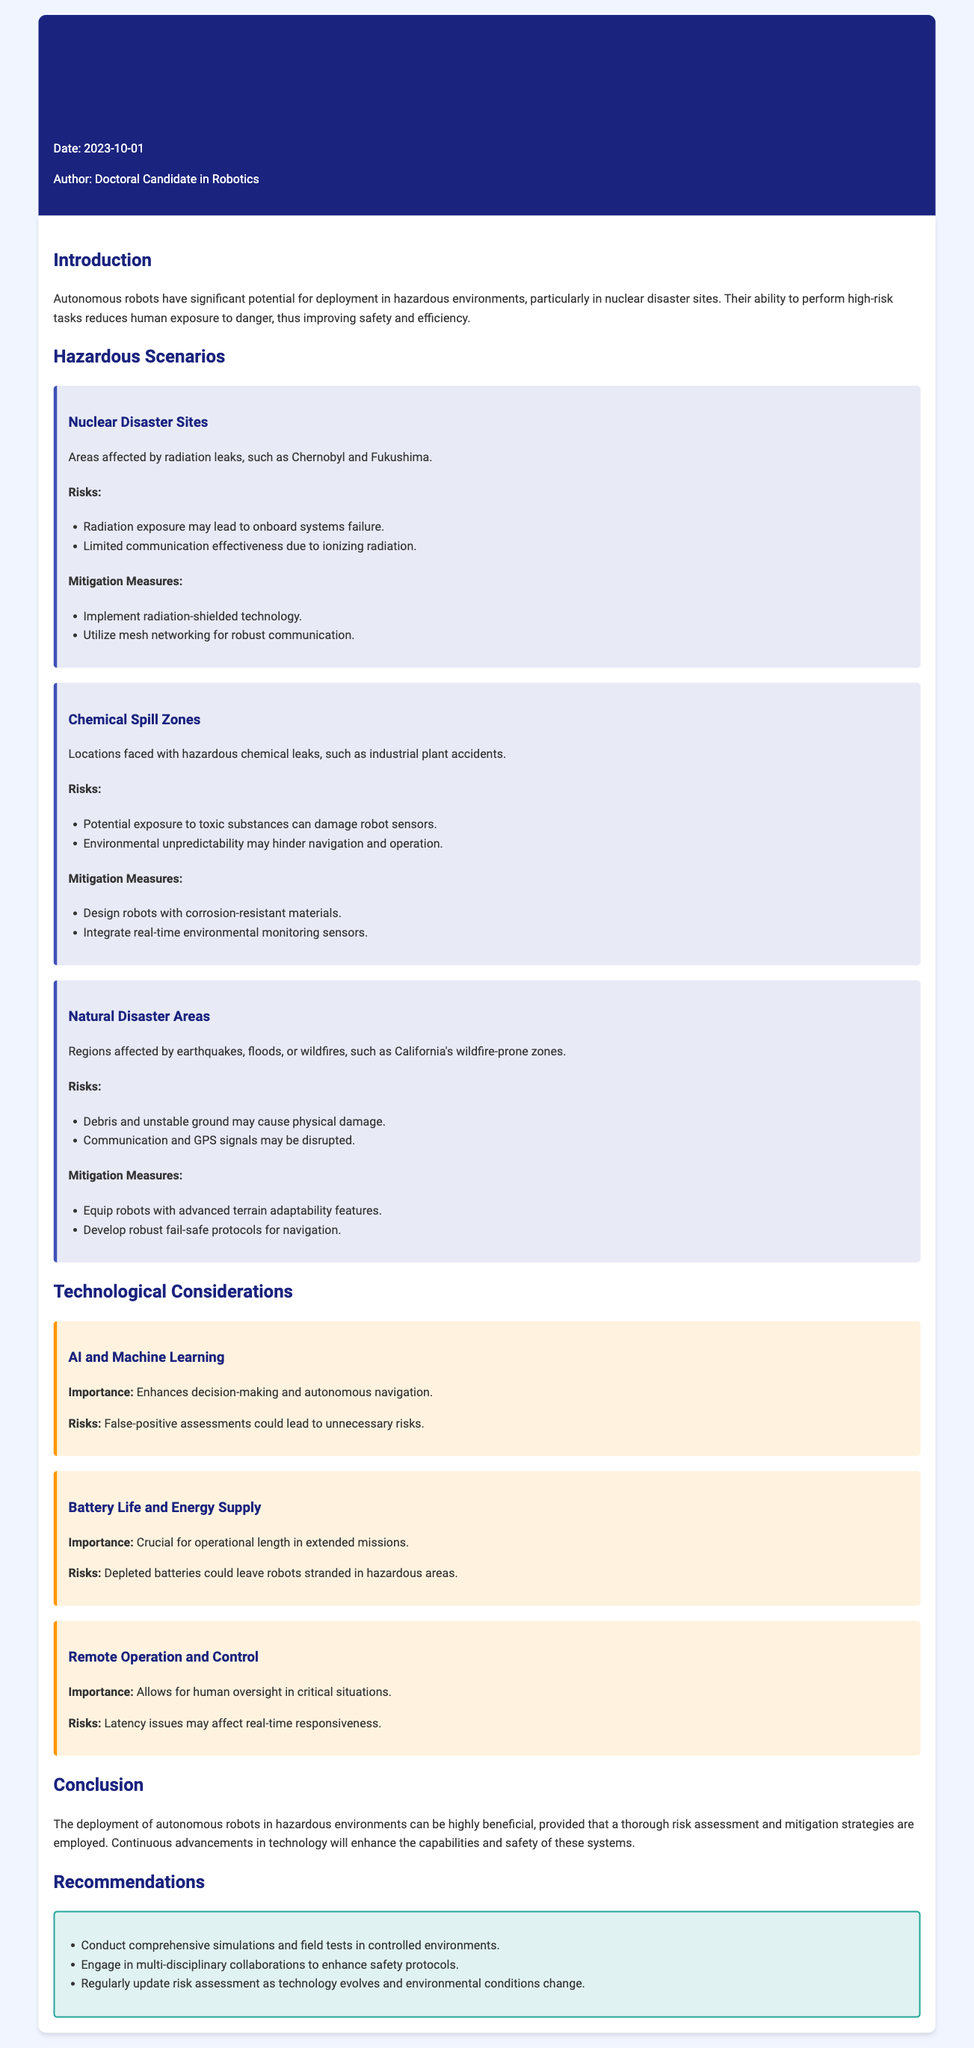What is the date of the report? The date of the report is stated in the memo header of the document.
Answer: 2023-10-01 Who is the author of the report? The author is identified in the memo header, which specifies the author's role.
Answer: Doctoral Candidate in Robotics What are the two main hazards in nuclear disaster sites? The risks associated with nuclear disaster sites are listed under the relevant scenario section.
Answer: Radiation exposure, Limited communication effectiveness What mitigation measures are proposed for chemical spill zones? Mitigation measures for chemical spill zones are provided in the document under that scenario.
Answer: Corrosion-resistant materials, Real-time environmental monitoring sensors How many hazardous scenarios are described in the report? The hazardous scenarios are numbered and listed in the document.
Answer: Three What is the importance of AI and Machine Learning in autonomous robots? The importance section under AI and Machine Learning outlines its impact.
Answer: Enhances decision-making and autonomous navigation What is a key recommendation made in the report? Recommendations are provided at the end of the document, offering specific suggestions.
Answer: Conduct comprehensive simulations and field tests What kind of scenarios are outlined in the report? The scenarios are categorized and detailed, providing context for the risks and considerations.
Answer: Nuclear Disaster Sites, Chemical Spill Zones, Natural Disaster Areas What concern is raised regarding battery life? The document outlines the risks of battery life in the technology considerations section.
Answer: Depleted batteries could leave robots stranded 